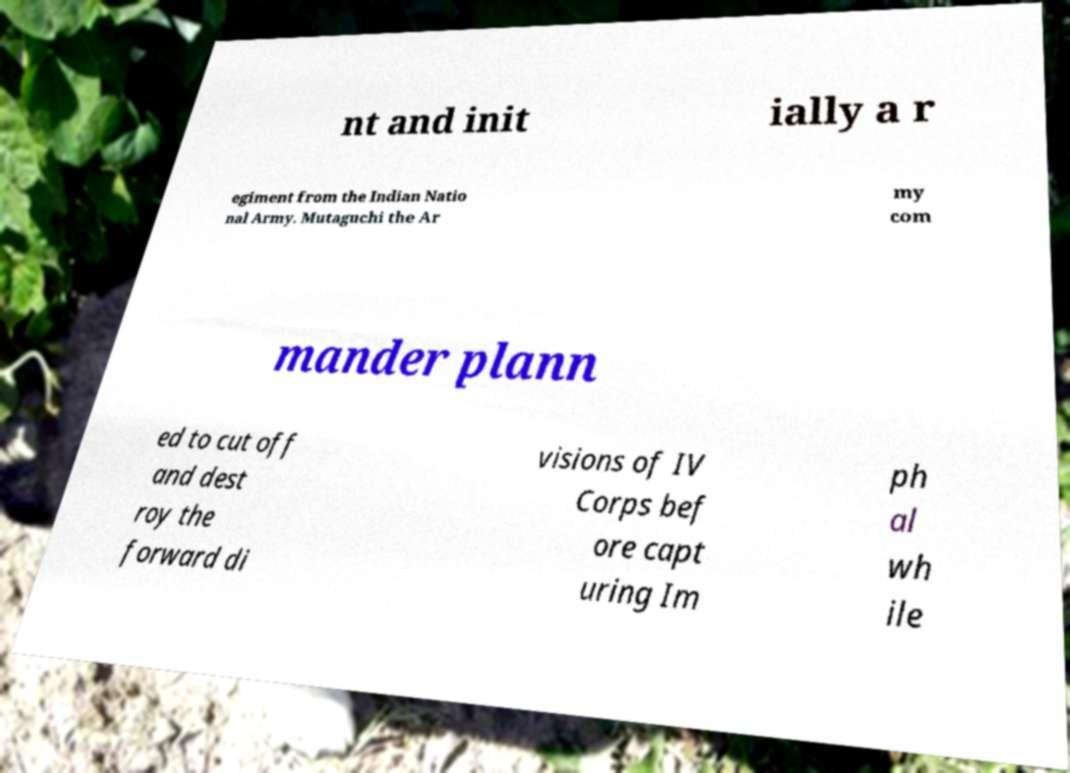There's text embedded in this image that I need extracted. Can you transcribe it verbatim? nt and init ially a r egiment from the Indian Natio nal Army. Mutaguchi the Ar my com mander plann ed to cut off and dest roy the forward di visions of IV Corps bef ore capt uring Im ph al wh ile 